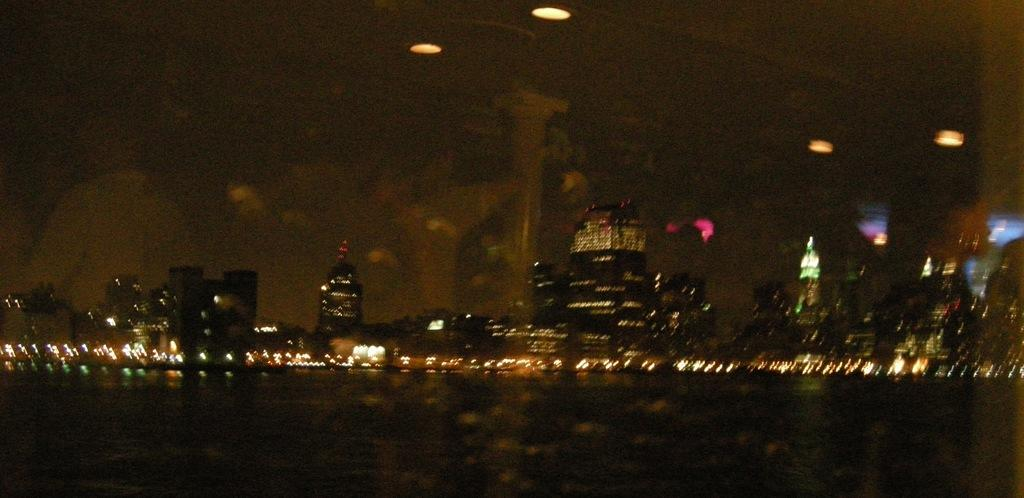What is the lighting condition in the image? The image was taken in the dark. What can be seen in the middle of the image? There are many buildings in the middle of the image. What is visible in the image besides the buildings? There are lights visible in the image. What is visible at the top of the image? The sky is visible at the top of the image. What else can be seen in the sky? There are lights in the sky. How many chairs are visible in the image? There are no chairs present in the image. What type of nation is depicted in the image? The image does not depict a nation; it shows buildings, lights, and the sky. 